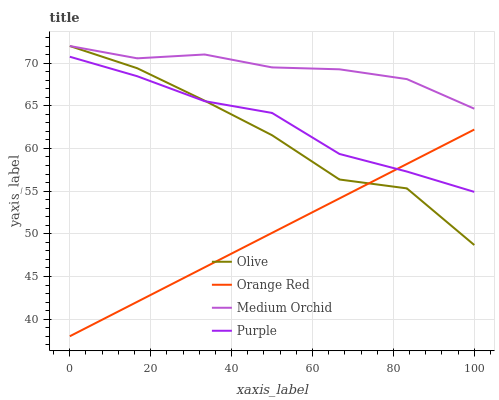Does Orange Red have the minimum area under the curve?
Answer yes or no. Yes. Does Medium Orchid have the maximum area under the curve?
Answer yes or no. Yes. Does Purple have the minimum area under the curve?
Answer yes or no. No. Does Purple have the maximum area under the curve?
Answer yes or no. No. Is Orange Red the smoothest?
Answer yes or no. Yes. Is Olive the roughest?
Answer yes or no. Yes. Is Purple the smoothest?
Answer yes or no. No. Is Purple the roughest?
Answer yes or no. No. Does Orange Red have the lowest value?
Answer yes or no. Yes. Does Purple have the lowest value?
Answer yes or no. No. Does Medium Orchid have the highest value?
Answer yes or no. Yes. Does Purple have the highest value?
Answer yes or no. No. Is Purple less than Medium Orchid?
Answer yes or no. Yes. Is Medium Orchid greater than Purple?
Answer yes or no. Yes. Does Olive intersect Medium Orchid?
Answer yes or no. Yes. Is Olive less than Medium Orchid?
Answer yes or no. No. Is Olive greater than Medium Orchid?
Answer yes or no. No. Does Purple intersect Medium Orchid?
Answer yes or no. No. 